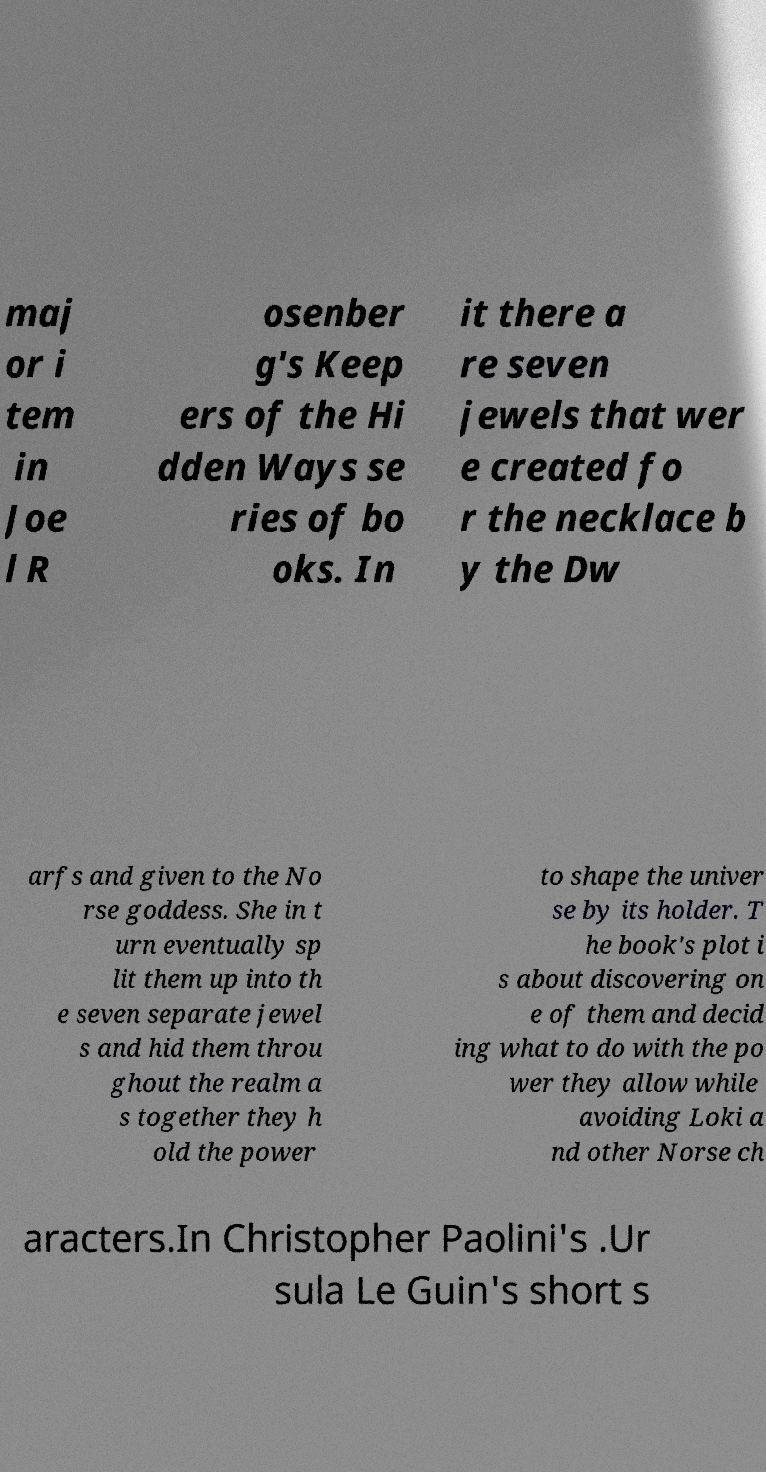Can you read and provide the text displayed in the image?This photo seems to have some interesting text. Can you extract and type it out for me? maj or i tem in Joe l R osenber g's Keep ers of the Hi dden Ways se ries of bo oks. In it there a re seven jewels that wer e created fo r the necklace b y the Dw arfs and given to the No rse goddess. She in t urn eventually sp lit them up into th e seven separate jewel s and hid them throu ghout the realm a s together they h old the power to shape the univer se by its holder. T he book's plot i s about discovering on e of them and decid ing what to do with the po wer they allow while avoiding Loki a nd other Norse ch aracters.In Christopher Paolini's .Ur sula Le Guin's short s 